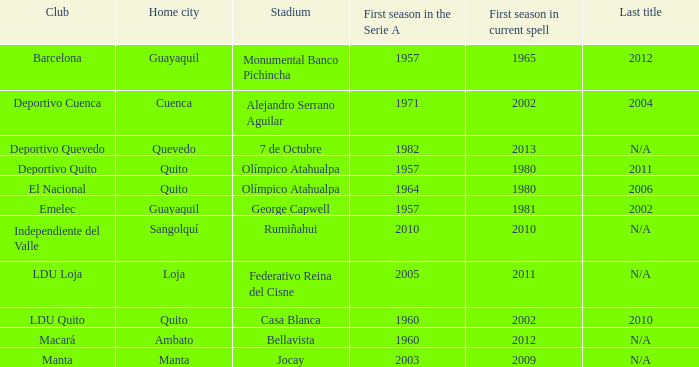Could you parse the entire table as a dict? {'header': ['Club', 'Home city', 'Stadium', 'First season in the Serie A', 'First season in current spell', 'Last title'], 'rows': [['Barcelona', 'Guayaquil', 'Monumental Banco Pichincha', '1957', '1965', '2012'], ['Deportivo Cuenca', 'Cuenca', 'Alejandro Serrano Aguilar', '1971', '2002', '2004'], ['Deportivo Quevedo', 'Quevedo', '7 de Octubre', '1982', '2013', 'N/A'], ['Deportivo Quito', 'Quito', 'Olímpico Atahualpa', '1957', '1980', '2011'], ['El Nacional', 'Quito', 'Olímpico Atahualpa', '1964', '1980', '2006'], ['Emelec', 'Guayaquil', 'George Capwell', '1957', '1981', '2002'], ['Independiente del Valle', 'Sangolquí', 'Rumiñahui', '2010', '2010', 'N/A'], ['LDU Loja', 'Loja', 'Federativo Reina del Cisne', '2005', '2011', 'N/A'], ['LDU Quito', 'Quito', 'Casa Blanca', '1960', '2002', '2010'], ['Macará', 'Ambato', 'Bellavista', '1960', '2012', 'N/A'], ['Manta', 'Manta', 'Jocay', '2003', '2009', 'N/A']]} Name the first season in the series for 2006 1964.0. 